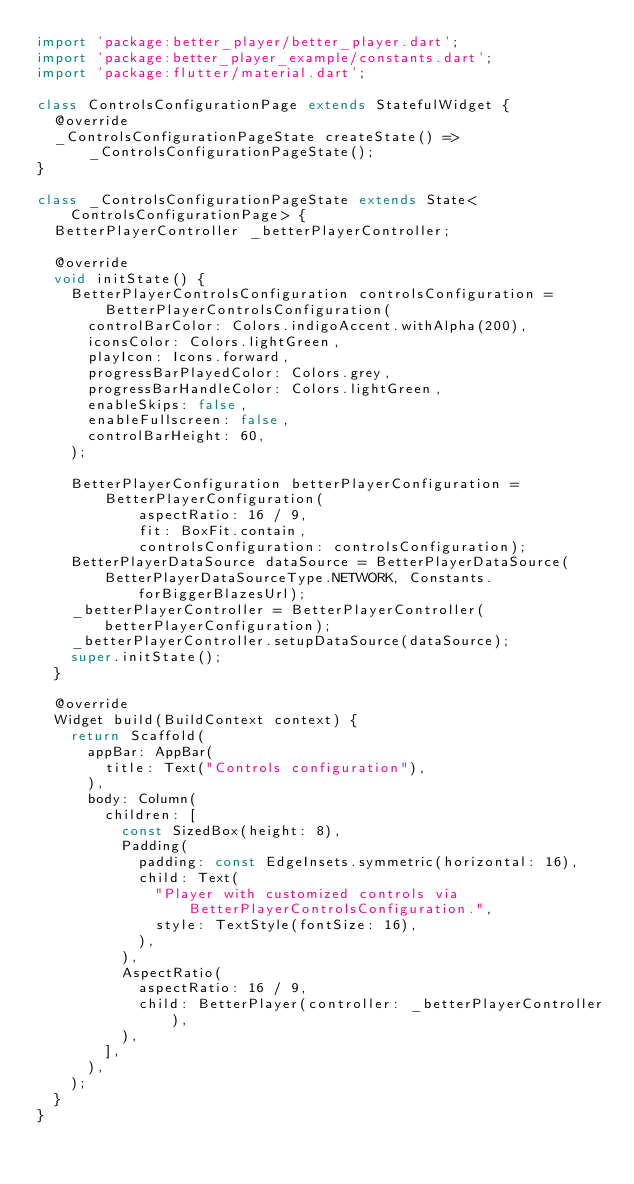Convert code to text. <code><loc_0><loc_0><loc_500><loc_500><_Dart_>import 'package:better_player/better_player.dart';
import 'package:better_player_example/constants.dart';
import 'package:flutter/material.dart';

class ControlsConfigurationPage extends StatefulWidget {
  @override
  _ControlsConfigurationPageState createState() =>
      _ControlsConfigurationPageState();
}

class _ControlsConfigurationPageState extends State<ControlsConfigurationPage> {
  BetterPlayerController _betterPlayerController;

  @override
  void initState() {
    BetterPlayerControlsConfiguration controlsConfiguration =
        BetterPlayerControlsConfiguration(
      controlBarColor: Colors.indigoAccent.withAlpha(200),
      iconsColor: Colors.lightGreen,
      playIcon: Icons.forward,
      progressBarPlayedColor: Colors.grey,
      progressBarHandleColor: Colors.lightGreen,
      enableSkips: false,
      enableFullscreen: false,
      controlBarHeight: 60,
    );

    BetterPlayerConfiguration betterPlayerConfiguration =
        BetterPlayerConfiguration(
            aspectRatio: 16 / 9,
            fit: BoxFit.contain,
            controlsConfiguration: controlsConfiguration);
    BetterPlayerDataSource dataSource = BetterPlayerDataSource(
        BetterPlayerDataSourceType.NETWORK, Constants.forBiggerBlazesUrl);
    _betterPlayerController = BetterPlayerController(betterPlayerConfiguration);
    _betterPlayerController.setupDataSource(dataSource);
    super.initState();
  }

  @override
  Widget build(BuildContext context) {
    return Scaffold(
      appBar: AppBar(
        title: Text("Controls configuration"),
      ),
      body: Column(
        children: [
          const SizedBox(height: 8),
          Padding(
            padding: const EdgeInsets.symmetric(horizontal: 16),
            child: Text(
              "Player with customized controls via BetterPlayerControlsConfiguration.",
              style: TextStyle(fontSize: 16),
            ),
          ),
          AspectRatio(
            aspectRatio: 16 / 9,
            child: BetterPlayer(controller: _betterPlayerController),
          ),
        ],
      ),
    );
  }
}
</code> 